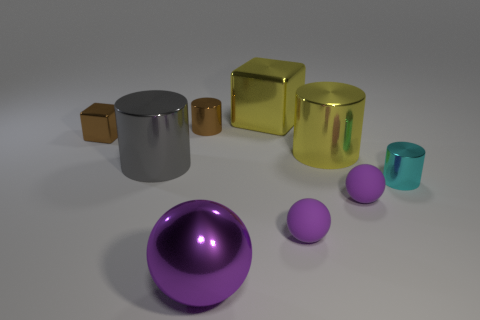Subtract all cyan spheres. Subtract all purple cylinders. How many spheres are left? 3 Add 1 gray things. How many objects exist? 10 Subtract all blocks. How many objects are left? 7 Add 3 small brown metal blocks. How many small brown metal blocks exist? 4 Subtract 0 green cylinders. How many objects are left? 9 Subtract all rubber spheres. Subtract all cylinders. How many objects are left? 3 Add 1 brown metallic cylinders. How many brown metallic cylinders are left? 2 